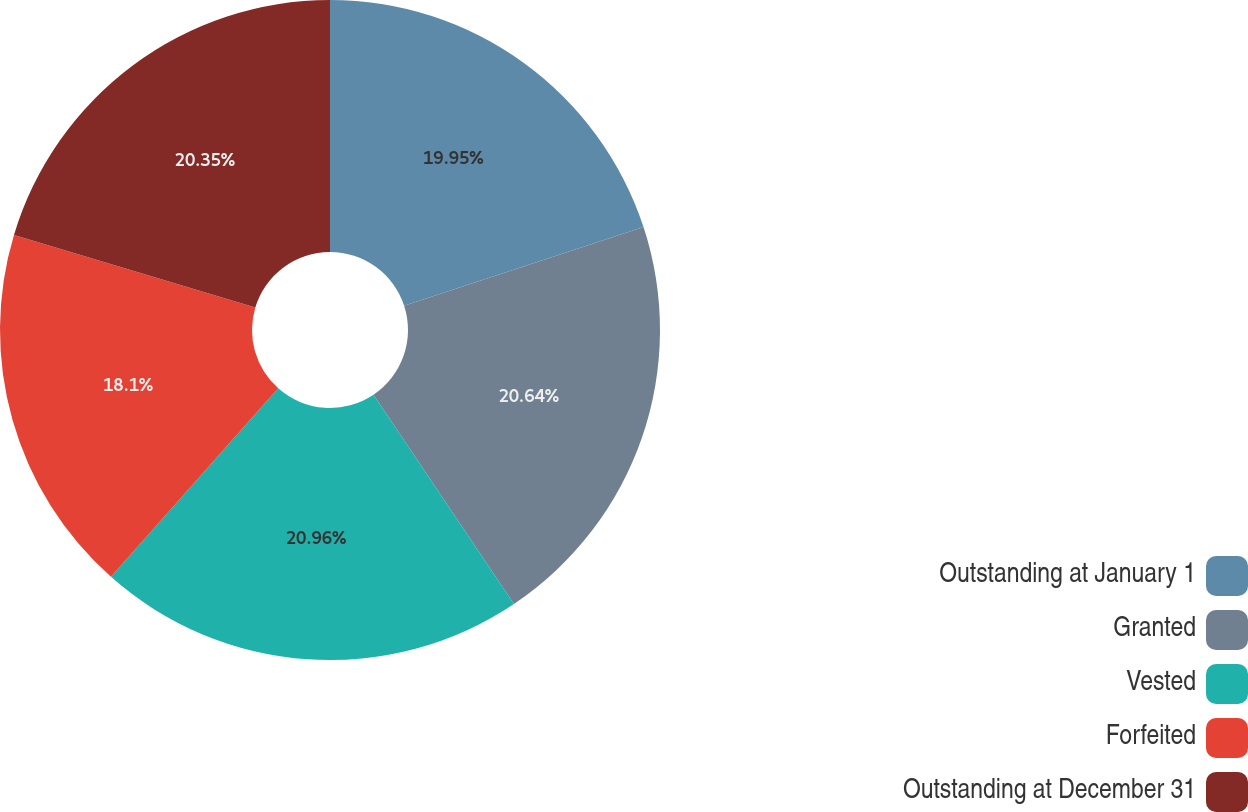Convert chart to OTSL. <chart><loc_0><loc_0><loc_500><loc_500><pie_chart><fcel>Outstanding at January 1<fcel>Granted<fcel>Vested<fcel>Forfeited<fcel>Outstanding at December 31<nl><fcel>19.95%<fcel>20.64%<fcel>20.96%<fcel>18.1%<fcel>20.35%<nl></chart> 